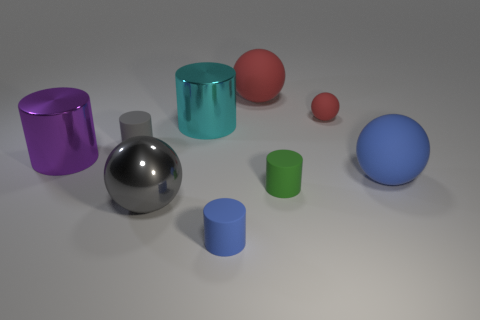Is there a small matte object of the same shape as the large gray object?
Provide a short and direct response. Yes. Does the large sphere that is behind the cyan metal cylinder have the same material as the blue thing that is to the left of the green rubber cylinder?
Ensure brevity in your answer.  Yes. There is a gray rubber object that is in front of the cyan object that is on the left side of the rubber thing in front of the metallic sphere; what is its size?
Offer a very short reply. Small. There is a cyan object that is the same size as the gray ball; what is it made of?
Keep it short and to the point. Metal. Are there any other cylinders of the same size as the green cylinder?
Your answer should be very brief. Yes. Do the large purple metal object and the small red rubber thing have the same shape?
Provide a short and direct response. No. There is a metal object behind the rubber thing that is on the left side of the gray metallic sphere; is there a small matte cylinder on the left side of it?
Ensure brevity in your answer.  Yes. How many other things are the same color as the big metallic sphere?
Give a very brief answer. 1. Does the gray object that is in front of the big blue matte sphere have the same size as the sphere that is behind the small red ball?
Keep it short and to the point. Yes. Are there an equal number of red rubber balls in front of the small blue cylinder and small rubber objects that are right of the big red thing?
Make the answer very short. No. 